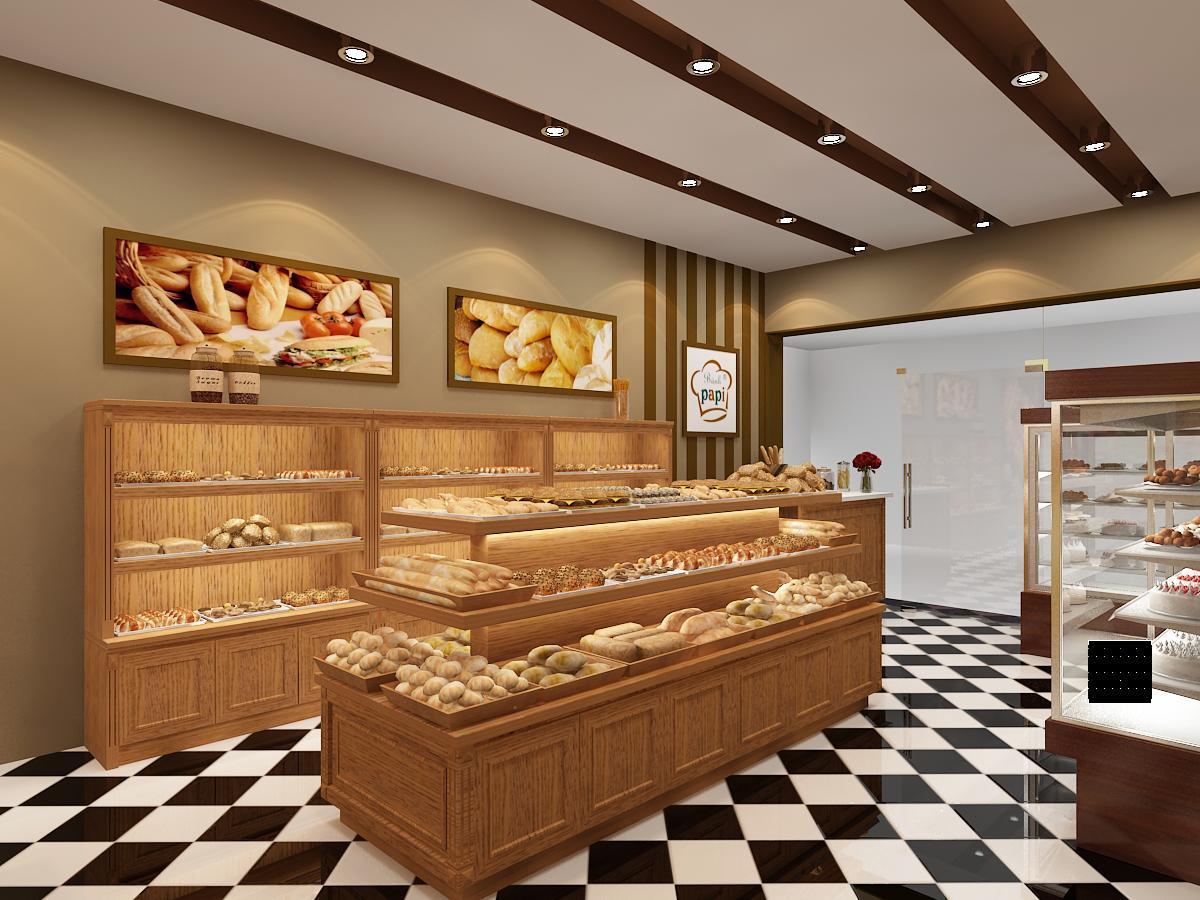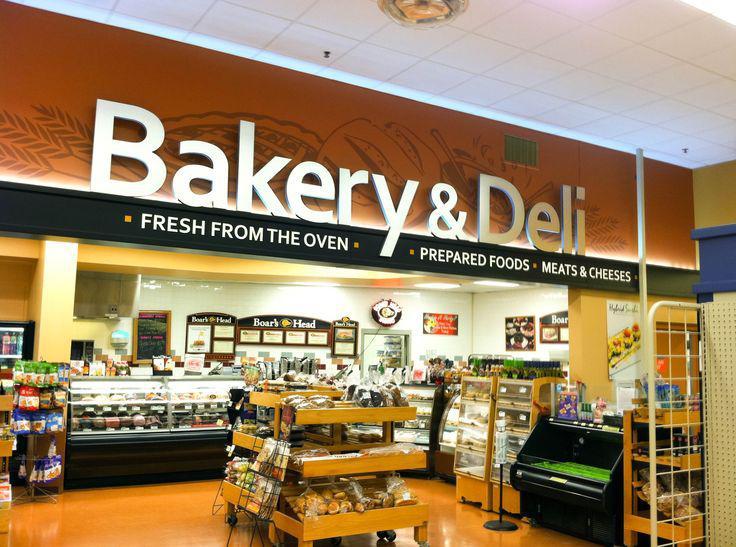The first image is the image on the left, the second image is the image on the right. Examine the images to the left and right. Is the description "One image shows a food establishment with a geometric pattern, black and white floor." accurate? Answer yes or no. Yes. The first image is the image on the left, the second image is the image on the right. For the images shown, is this caption "there are chairs in the image on the right." true? Answer yes or no. No. 